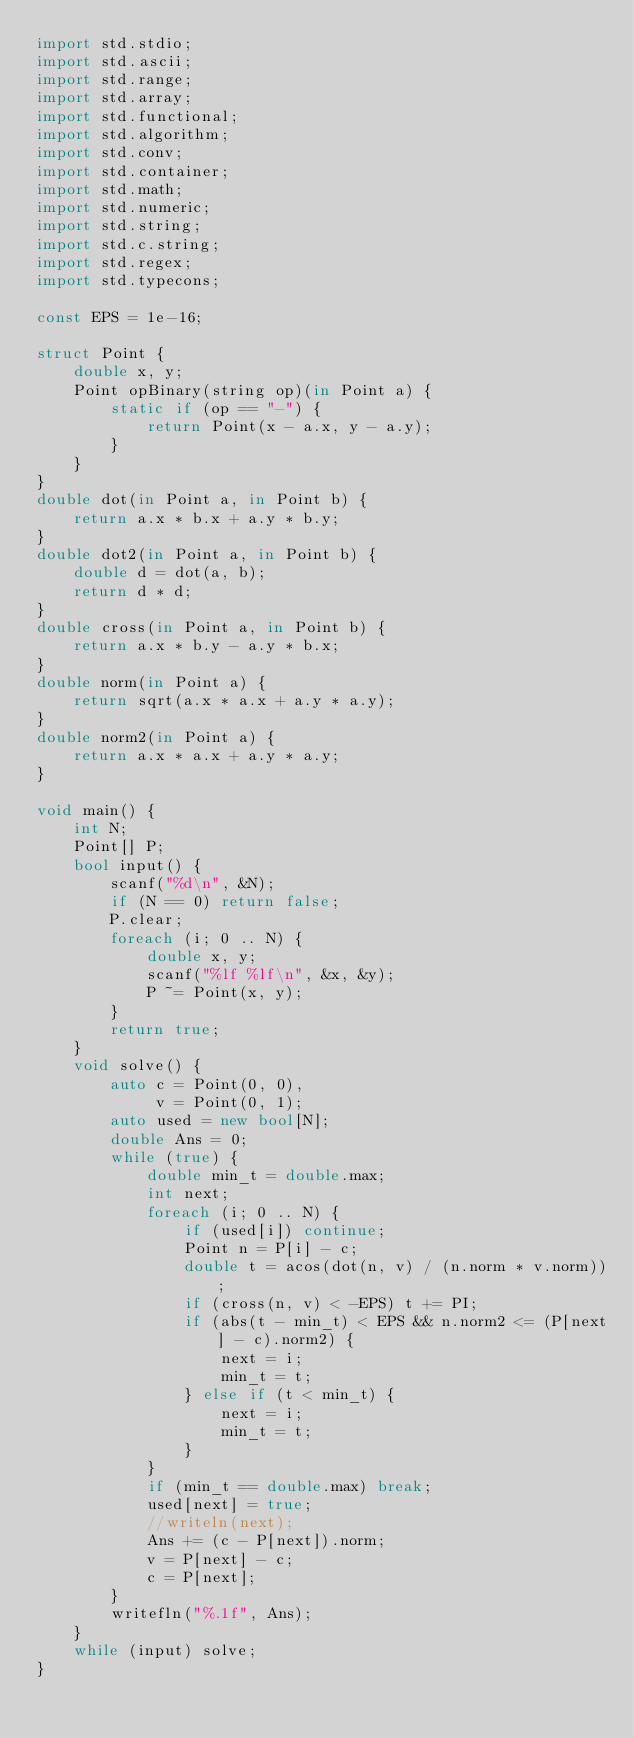<code> <loc_0><loc_0><loc_500><loc_500><_D_>import std.stdio;
import std.ascii;
import std.range;
import std.array;
import std.functional;
import std.algorithm;
import std.conv;
import std.container;
import std.math;
import std.numeric;
import std.string;
import std.c.string;
import std.regex;
import std.typecons;

const EPS = 1e-16;

struct Point {
    double x, y;
    Point opBinary(string op)(in Point a) {
        static if (op == "-") {
            return Point(x - a.x, y - a.y);
        }
    }
}
double dot(in Point a, in Point b) {
    return a.x * b.x + a.y * b.y;
}
double dot2(in Point a, in Point b) {
    double d = dot(a, b);
    return d * d;
}
double cross(in Point a, in Point b) {
    return a.x * b.y - a.y * b.x;
}
double norm(in Point a) {
    return sqrt(a.x * a.x + a.y * a.y);
}
double norm2(in Point a) {
    return a.x * a.x + a.y * a.y;
}

void main() {
    int N;
    Point[] P;
    bool input() {
        scanf("%d\n", &N);
        if (N == 0) return false;
        P.clear;
        foreach (i; 0 .. N) {
            double x, y;
            scanf("%lf %lf\n", &x, &y);
            P ~= Point(x, y);
        }
        return true;
    }
    void solve() {
        auto c = Point(0, 0),
             v = Point(0, 1);
        auto used = new bool[N];
        double Ans = 0;
        while (true) {
            double min_t = double.max;
            int next;
            foreach (i; 0 .. N) {
                if (used[i]) continue;
                Point n = P[i] - c;
                double t = acos(dot(n, v) / (n.norm * v.norm));
                if (cross(n, v) < -EPS) t += PI;
                if (abs(t - min_t) < EPS && n.norm2 <= (P[next] - c).norm2) {
                    next = i;
                    min_t = t;
                } else if (t < min_t) {
                    next = i;
                    min_t = t;
                }
            }
            if (min_t == double.max) break;
            used[next] = true;
            //writeln(next);
            Ans += (c - P[next]).norm;
            v = P[next] - c;
            c = P[next];
        }
        writefln("%.1f", Ans);
    }
    while (input) solve;
}</code> 